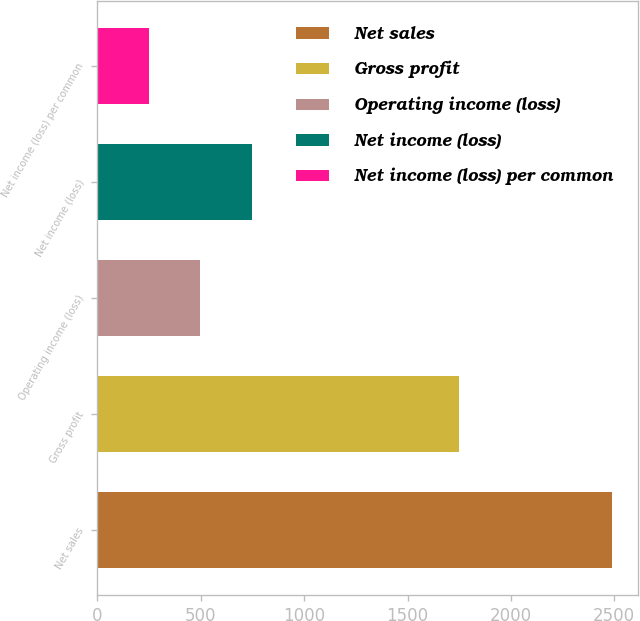<chart> <loc_0><loc_0><loc_500><loc_500><bar_chart><fcel>Net sales<fcel>Gross profit<fcel>Operating income (loss)<fcel>Net income (loss)<fcel>Net income (loss) per common<nl><fcel>2490<fcel>1751<fcel>498.32<fcel>747.28<fcel>249.36<nl></chart> 